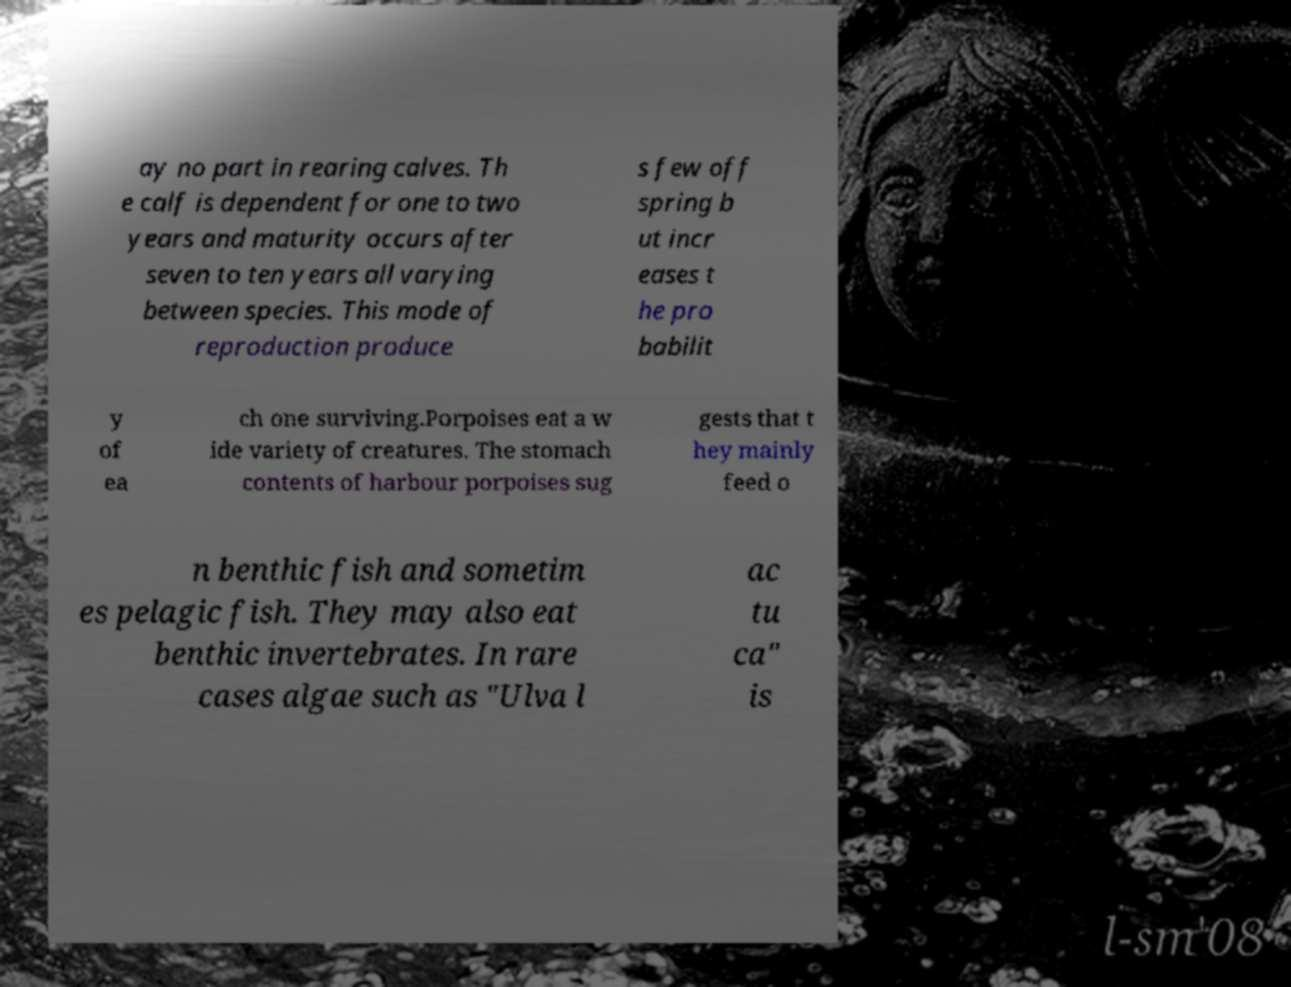Could you assist in decoding the text presented in this image and type it out clearly? ay no part in rearing calves. Th e calf is dependent for one to two years and maturity occurs after seven to ten years all varying between species. This mode of reproduction produce s few off spring b ut incr eases t he pro babilit y of ea ch one surviving.Porpoises eat a w ide variety of creatures. The stomach contents of harbour porpoises sug gests that t hey mainly feed o n benthic fish and sometim es pelagic fish. They may also eat benthic invertebrates. In rare cases algae such as "Ulva l ac tu ca" is 